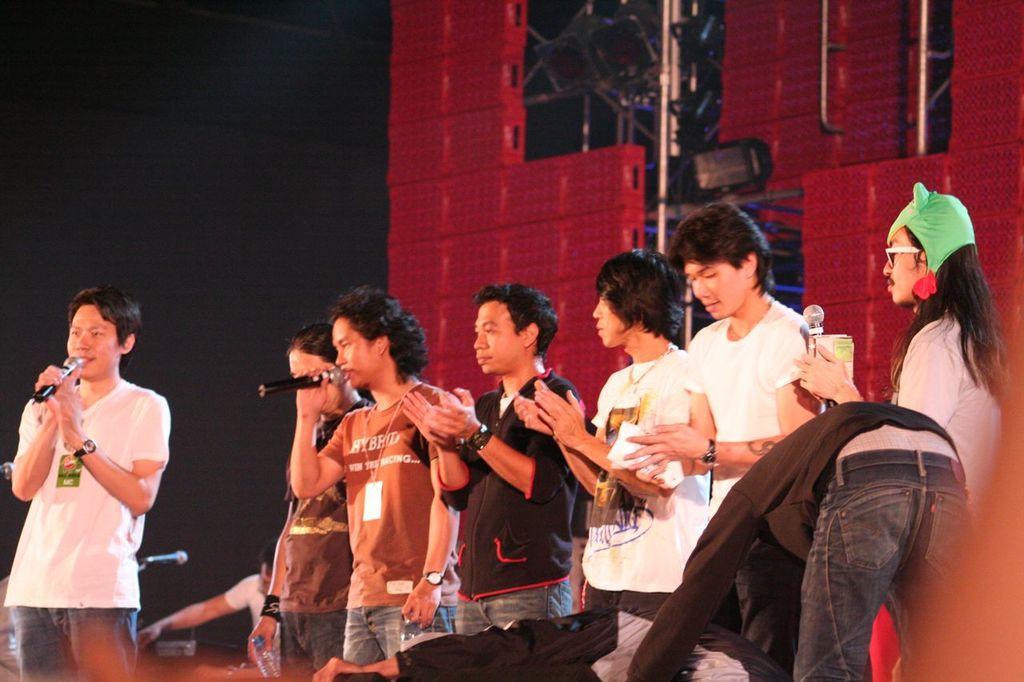In one or two sentences, can you explain what this image depicts? In this image, there are some people standing, we can see some people are holding the microphones, in the background there are some red color boxes and we can see a light. 